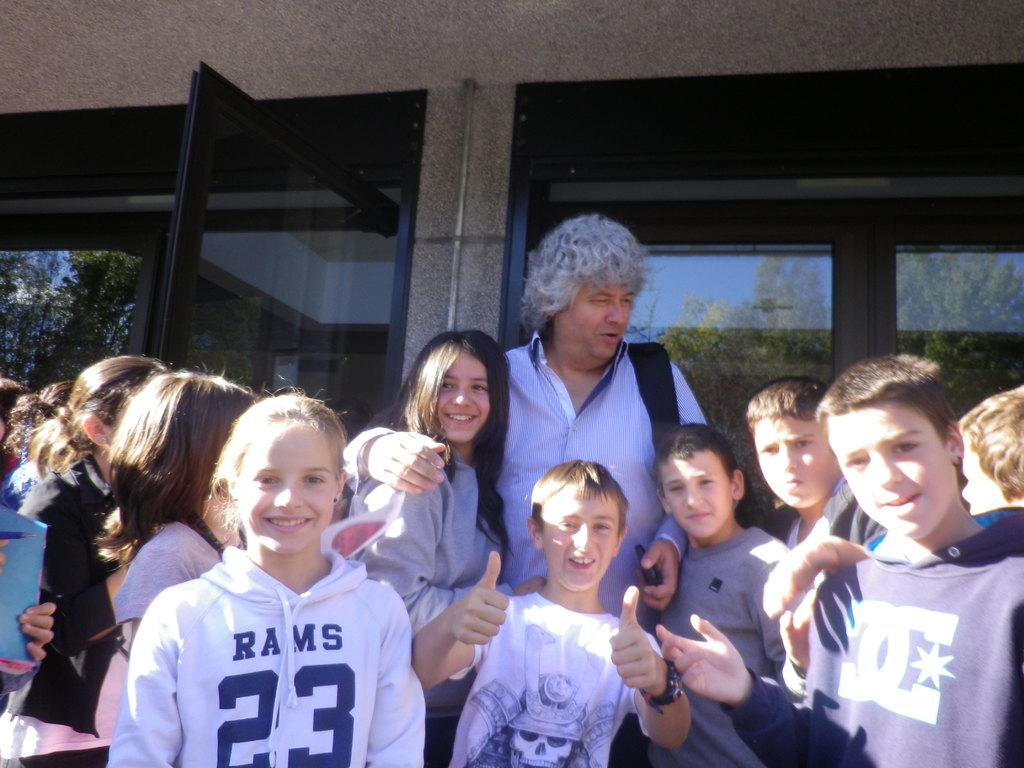How many people are in the image? There is a group of people in the image. What can be seen in the background of the image? There are glass doors in the background of the image. What is reflected in the glass doors? The reflection of trees and the sky is visible in the glass doors. What type of eggnog is being served in the image? There is no eggnog present in the image. What color is the orange in the image? There is no orange present in the image. 